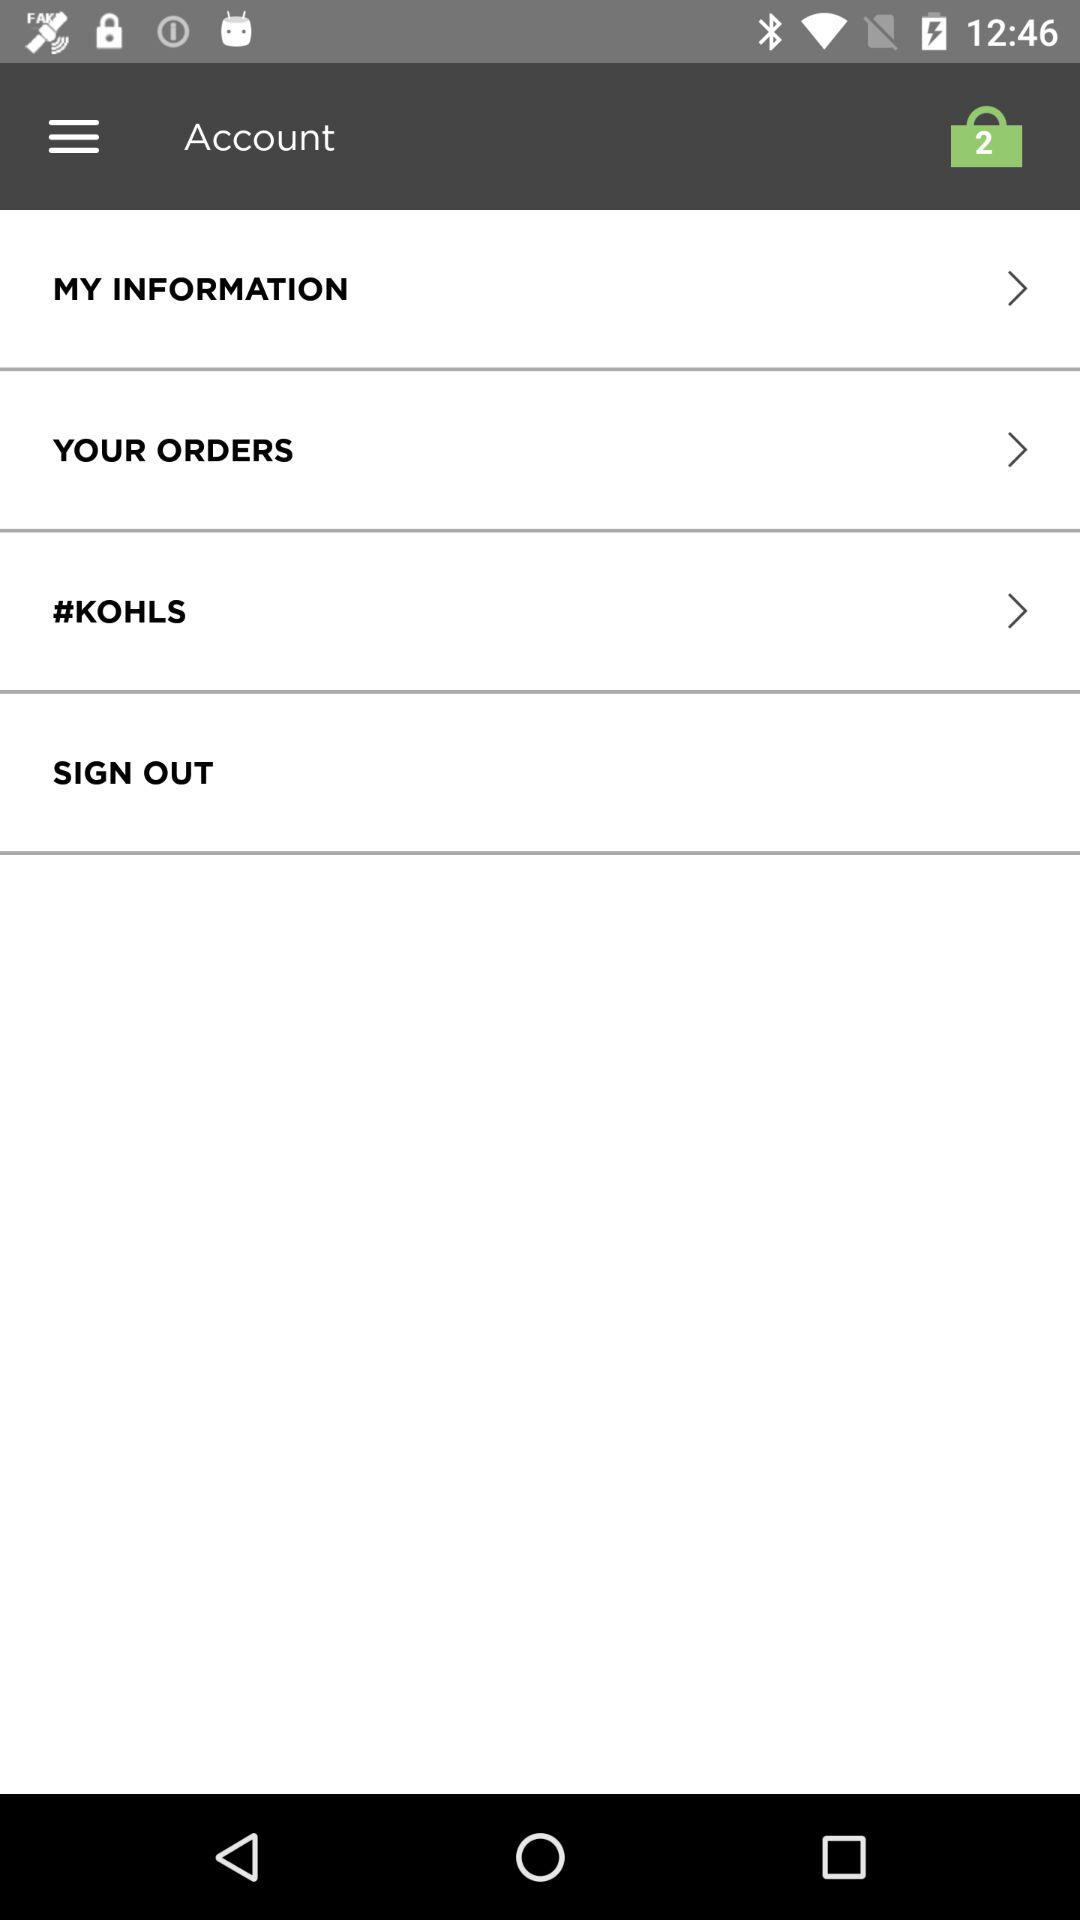How many items are there in the cart? There are 2 items in the cart. 